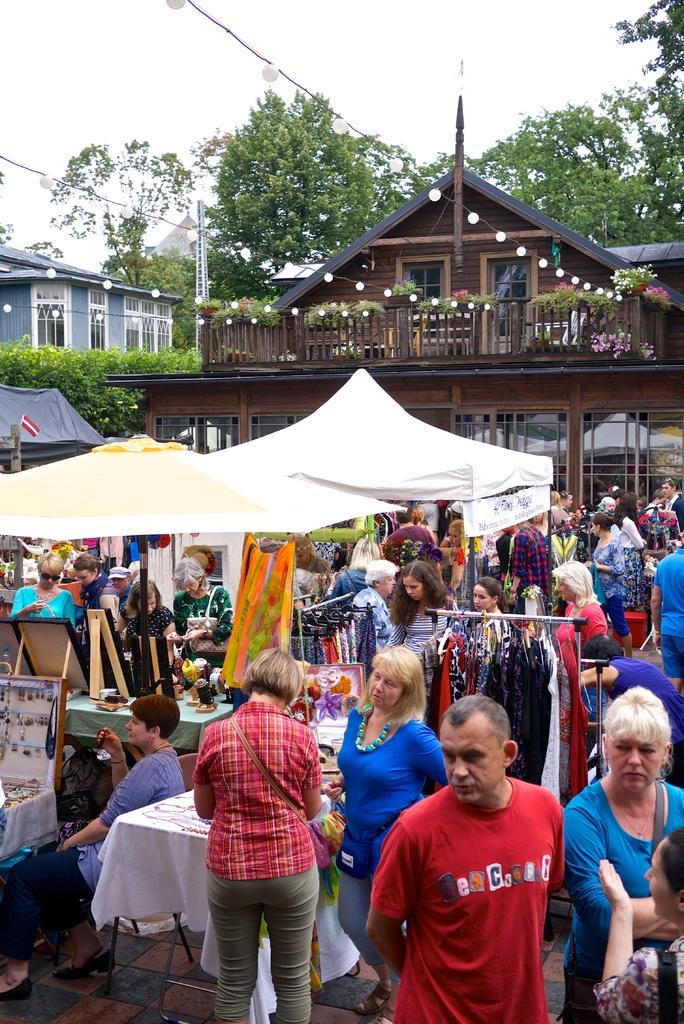What is happening in the image? There is a group of people standing on the right side of the image. What can be seen in the background of the image? Shops, a tent, other buildings, and trees are present in the background. What type of ink is being used by the people in the image? There is no ink present in the image; it features a group of people standing and various elements in the background. 